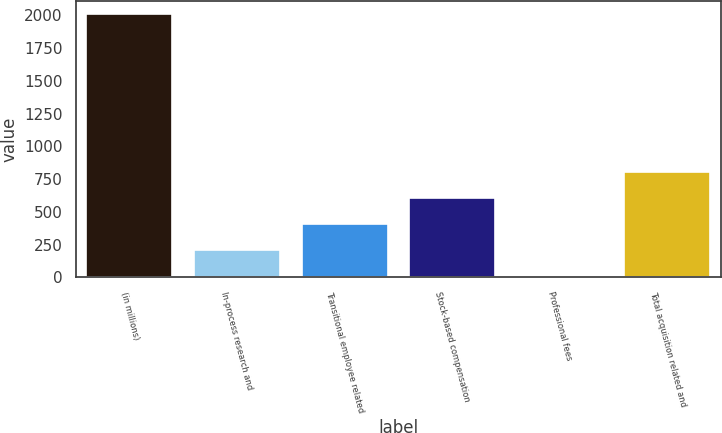<chart> <loc_0><loc_0><loc_500><loc_500><bar_chart><fcel>(in millions)<fcel>In-process research and<fcel>Transitional employee related<fcel>Stock-based compensation<fcel>Professional fees<fcel>Total acquisition related and<nl><fcel>2008<fcel>207.1<fcel>407.2<fcel>607.3<fcel>7<fcel>807.4<nl></chart> 